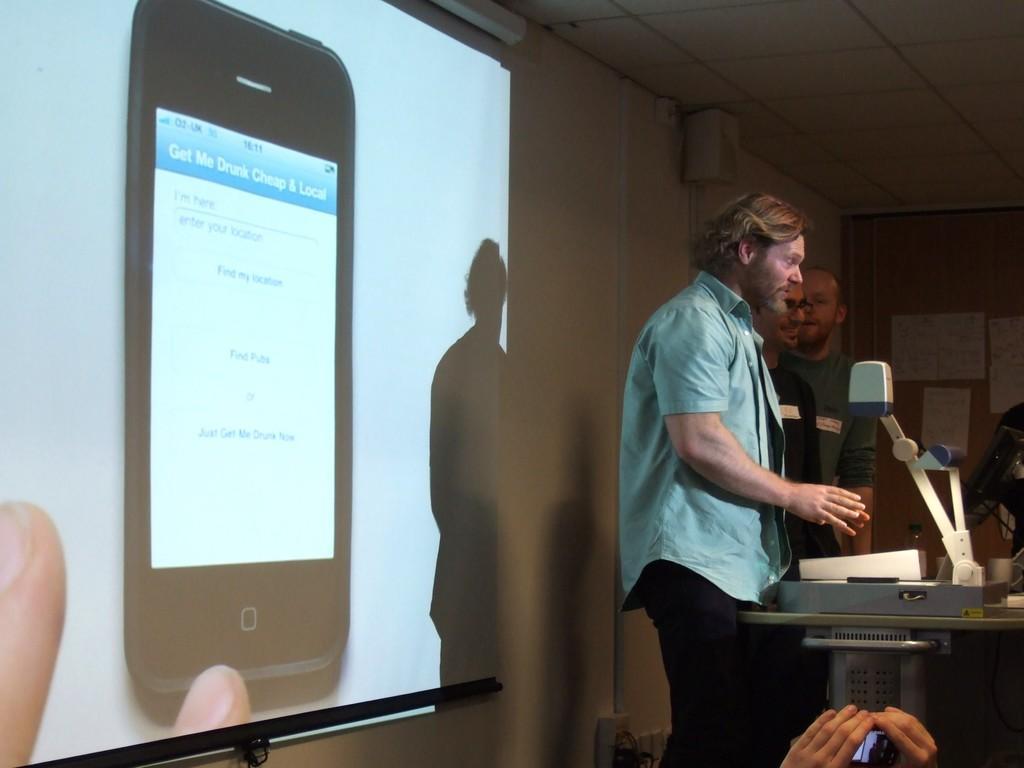Could you give a brief overview of what you see in this image? On the right side of the picture there are people, table and an electronic gadget. At the bottom there is a person holding mobile. On the left it is projector screen, on the screen there is a mobile phone. 